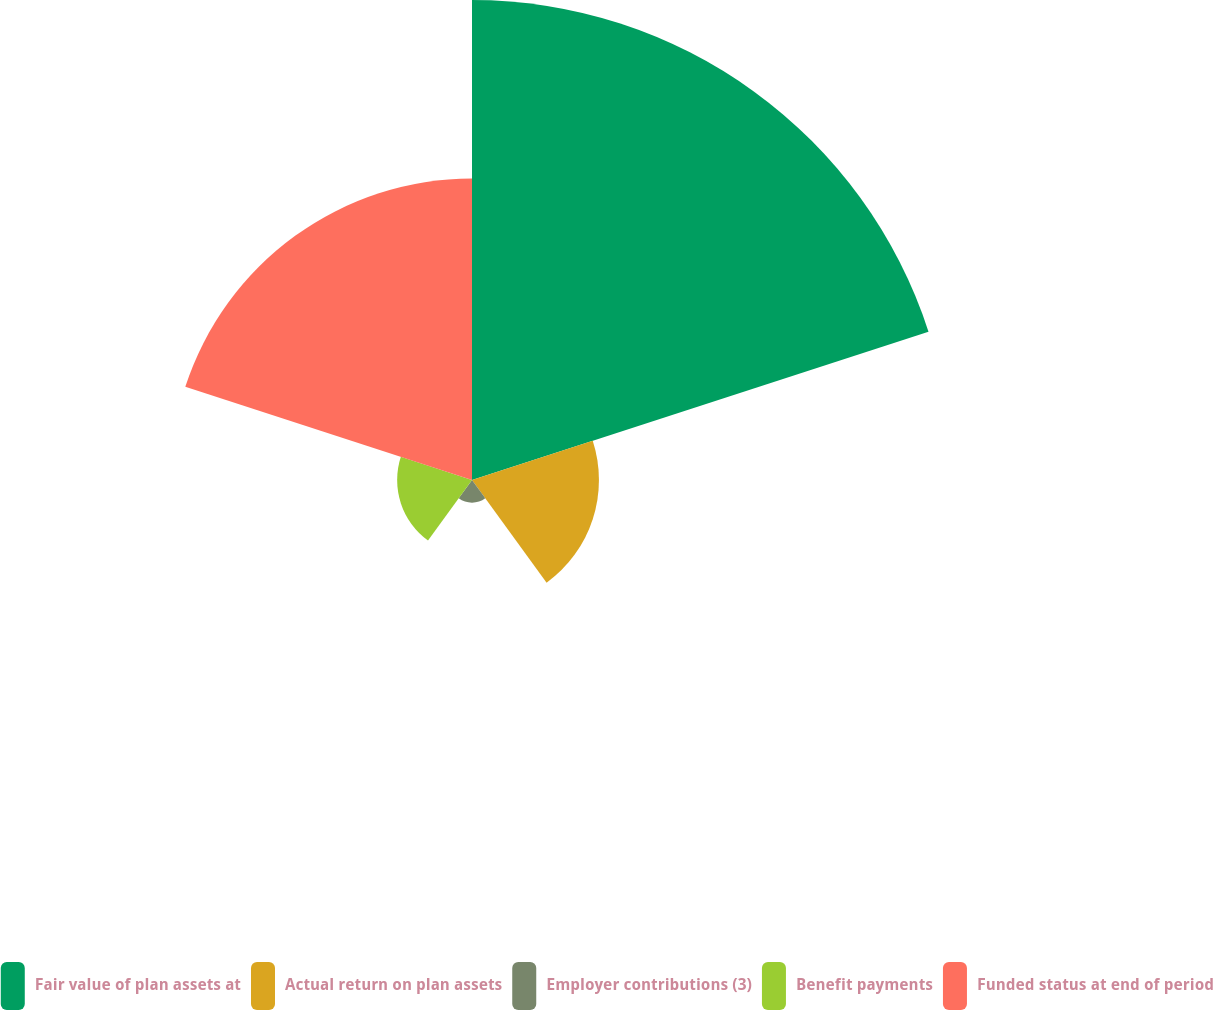Convert chart to OTSL. <chart><loc_0><loc_0><loc_500><loc_500><pie_chart><fcel>Fair value of plan assets at<fcel>Actual return on plan assets<fcel>Employer contributions (3)<fcel>Benefit payments<fcel>Funded status at end of period<nl><fcel>47.72%<fcel>12.62%<fcel>2.25%<fcel>7.44%<fcel>29.97%<nl></chart> 